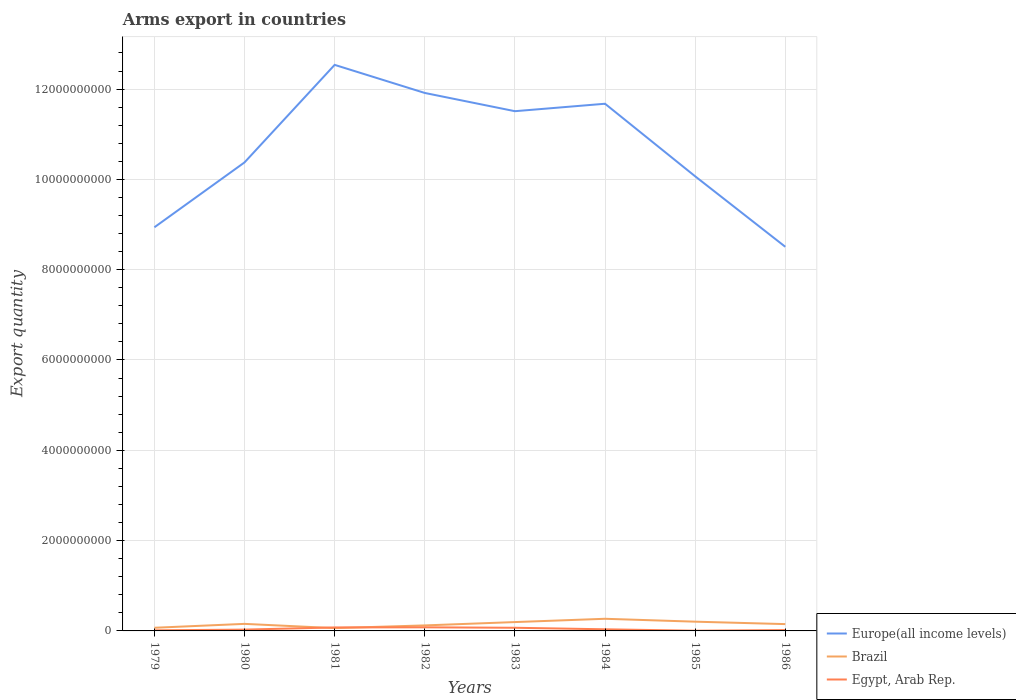Does the line corresponding to Egypt, Arab Rep. intersect with the line corresponding to Europe(all income levels)?
Ensure brevity in your answer.  No. Across all years, what is the maximum total arms export in Egypt, Arab Rep.?
Your response must be concise. 5.00e+06. In which year was the total arms export in Egypt, Arab Rep. maximum?
Your answer should be compact. 1985. What is the total total arms export in Europe(all income levels) in the graph?
Provide a short and direct response. 2.39e+08. What is the difference between the highest and the second highest total arms export in Egypt, Arab Rep.?
Your answer should be very brief. 7.50e+07. What is the difference between the highest and the lowest total arms export in Brazil?
Provide a short and direct response. 4. How many years are there in the graph?
Give a very brief answer. 8. Are the values on the major ticks of Y-axis written in scientific E-notation?
Provide a short and direct response. No. Does the graph contain grids?
Provide a short and direct response. Yes. How many legend labels are there?
Your answer should be very brief. 3. How are the legend labels stacked?
Offer a terse response. Vertical. What is the title of the graph?
Make the answer very short. Arms export in countries. Does "Jamaica" appear as one of the legend labels in the graph?
Your answer should be compact. No. What is the label or title of the X-axis?
Your answer should be very brief. Years. What is the label or title of the Y-axis?
Keep it short and to the point. Export quantity. What is the Export quantity of Europe(all income levels) in 1979?
Provide a succinct answer. 8.94e+09. What is the Export quantity of Brazil in 1979?
Give a very brief answer. 7.00e+07. What is the Export quantity in Egypt, Arab Rep. in 1979?
Your response must be concise. 1.30e+07. What is the Export quantity of Europe(all income levels) in 1980?
Ensure brevity in your answer.  1.04e+1. What is the Export quantity of Brazil in 1980?
Provide a succinct answer. 1.56e+08. What is the Export quantity in Egypt, Arab Rep. in 1980?
Provide a succinct answer. 2.90e+07. What is the Export quantity in Europe(all income levels) in 1981?
Make the answer very short. 1.25e+1. What is the Export quantity in Brazil in 1981?
Keep it short and to the point. 6.20e+07. What is the Export quantity in Egypt, Arab Rep. in 1981?
Your answer should be very brief. 7.70e+07. What is the Export quantity of Europe(all income levels) in 1982?
Provide a short and direct response. 1.19e+1. What is the Export quantity in Brazil in 1982?
Your response must be concise. 1.22e+08. What is the Export quantity in Egypt, Arab Rep. in 1982?
Give a very brief answer. 8.00e+07. What is the Export quantity of Europe(all income levels) in 1983?
Keep it short and to the point. 1.15e+1. What is the Export quantity of Brazil in 1983?
Keep it short and to the point. 1.96e+08. What is the Export quantity in Egypt, Arab Rep. in 1983?
Your response must be concise. 7.00e+07. What is the Export quantity of Europe(all income levels) in 1984?
Your answer should be compact. 1.17e+1. What is the Export quantity in Brazil in 1984?
Give a very brief answer. 2.69e+08. What is the Export quantity in Egypt, Arab Rep. in 1984?
Your response must be concise. 3.60e+07. What is the Export quantity in Europe(all income levels) in 1985?
Your response must be concise. 1.01e+1. What is the Export quantity of Brazil in 1985?
Make the answer very short. 2.05e+08. What is the Export quantity of Egypt, Arab Rep. in 1985?
Make the answer very short. 5.00e+06. What is the Export quantity of Europe(all income levels) in 1986?
Offer a very short reply. 8.51e+09. What is the Export quantity in Brazil in 1986?
Make the answer very short. 1.51e+08. What is the Export quantity in Egypt, Arab Rep. in 1986?
Provide a short and direct response. 1.90e+07. Across all years, what is the maximum Export quantity of Europe(all income levels)?
Provide a short and direct response. 1.25e+1. Across all years, what is the maximum Export quantity of Brazil?
Provide a short and direct response. 2.69e+08. Across all years, what is the maximum Export quantity in Egypt, Arab Rep.?
Your answer should be compact. 8.00e+07. Across all years, what is the minimum Export quantity of Europe(all income levels)?
Keep it short and to the point. 8.51e+09. Across all years, what is the minimum Export quantity of Brazil?
Give a very brief answer. 6.20e+07. What is the total Export quantity of Europe(all income levels) in the graph?
Provide a short and direct response. 8.55e+1. What is the total Export quantity in Brazil in the graph?
Keep it short and to the point. 1.23e+09. What is the total Export quantity in Egypt, Arab Rep. in the graph?
Provide a succinct answer. 3.29e+08. What is the difference between the Export quantity in Europe(all income levels) in 1979 and that in 1980?
Your answer should be compact. -1.44e+09. What is the difference between the Export quantity in Brazil in 1979 and that in 1980?
Keep it short and to the point. -8.60e+07. What is the difference between the Export quantity of Egypt, Arab Rep. in 1979 and that in 1980?
Your response must be concise. -1.60e+07. What is the difference between the Export quantity in Europe(all income levels) in 1979 and that in 1981?
Your answer should be very brief. -3.60e+09. What is the difference between the Export quantity in Egypt, Arab Rep. in 1979 and that in 1981?
Provide a succinct answer. -6.40e+07. What is the difference between the Export quantity in Europe(all income levels) in 1979 and that in 1982?
Your answer should be compact. -2.98e+09. What is the difference between the Export quantity of Brazil in 1979 and that in 1982?
Keep it short and to the point. -5.20e+07. What is the difference between the Export quantity in Egypt, Arab Rep. in 1979 and that in 1982?
Provide a succinct answer. -6.70e+07. What is the difference between the Export quantity of Europe(all income levels) in 1979 and that in 1983?
Provide a succinct answer. -2.57e+09. What is the difference between the Export quantity of Brazil in 1979 and that in 1983?
Your answer should be very brief. -1.26e+08. What is the difference between the Export quantity of Egypt, Arab Rep. in 1979 and that in 1983?
Your answer should be very brief. -5.70e+07. What is the difference between the Export quantity in Europe(all income levels) in 1979 and that in 1984?
Your answer should be very brief. -2.74e+09. What is the difference between the Export quantity of Brazil in 1979 and that in 1984?
Keep it short and to the point. -1.99e+08. What is the difference between the Export quantity of Egypt, Arab Rep. in 1979 and that in 1984?
Provide a succinct answer. -2.30e+07. What is the difference between the Export quantity of Europe(all income levels) in 1979 and that in 1985?
Your response must be concise. -1.13e+09. What is the difference between the Export quantity in Brazil in 1979 and that in 1985?
Keep it short and to the point. -1.35e+08. What is the difference between the Export quantity in Egypt, Arab Rep. in 1979 and that in 1985?
Your answer should be very brief. 8.00e+06. What is the difference between the Export quantity in Europe(all income levels) in 1979 and that in 1986?
Provide a succinct answer. 4.32e+08. What is the difference between the Export quantity in Brazil in 1979 and that in 1986?
Keep it short and to the point. -8.10e+07. What is the difference between the Export quantity in Egypt, Arab Rep. in 1979 and that in 1986?
Make the answer very short. -6.00e+06. What is the difference between the Export quantity of Europe(all income levels) in 1980 and that in 1981?
Provide a short and direct response. -2.16e+09. What is the difference between the Export quantity of Brazil in 1980 and that in 1981?
Your response must be concise. 9.40e+07. What is the difference between the Export quantity in Egypt, Arab Rep. in 1980 and that in 1981?
Your answer should be very brief. -4.80e+07. What is the difference between the Export quantity of Europe(all income levels) in 1980 and that in 1982?
Give a very brief answer. -1.54e+09. What is the difference between the Export quantity in Brazil in 1980 and that in 1982?
Provide a short and direct response. 3.40e+07. What is the difference between the Export quantity of Egypt, Arab Rep. in 1980 and that in 1982?
Give a very brief answer. -5.10e+07. What is the difference between the Export quantity of Europe(all income levels) in 1980 and that in 1983?
Your response must be concise. -1.13e+09. What is the difference between the Export quantity of Brazil in 1980 and that in 1983?
Offer a very short reply. -4.00e+07. What is the difference between the Export quantity in Egypt, Arab Rep. in 1980 and that in 1983?
Your answer should be very brief. -4.10e+07. What is the difference between the Export quantity in Europe(all income levels) in 1980 and that in 1984?
Keep it short and to the point. -1.30e+09. What is the difference between the Export quantity in Brazil in 1980 and that in 1984?
Your answer should be very brief. -1.13e+08. What is the difference between the Export quantity in Egypt, Arab Rep. in 1980 and that in 1984?
Offer a very short reply. -7.00e+06. What is the difference between the Export quantity in Europe(all income levels) in 1980 and that in 1985?
Make the answer very short. 3.08e+08. What is the difference between the Export quantity in Brazil in 1980 and that in 1985?
Keep it short and to the point. -4.90e+07. What is the difference between the Export quantity in Egypt, Arab Rep. in 1980 and that in 1985?
Your answer should be compact. 2.40e+07. What is the difference between the Export quantity in Europe(all income levels) in 1980 and that in 1986?
Your answer should be very brief. 1.87e+09. What is the difference between the Export quantity in Brazil in 1980 and that in 1986?
Your response must be concise. 5.00e+06. What is the difference between the Export quantity in Europe(all income levels) in 1981 and that in 1982?
Provide a succinct answer. 6.22e+08. What is the difference between the Export quantity of Brazil in 1981 and that in 1982?
Your answer should be compact. -6.00e+07. What is the difference between the Export quantity in Egypt, Arab Rep. in 1981 and that in 1982?
Make the answer very short. -3.00e+06. What is the difference between the Export quantity of Europe(all income levels) in 1981 and that in 1983?
Ensure brevity in your answer.  1.03e+09. What is the difference between the Export quantity in Brazil in 1981 and that in 1983?
Provide a succinct answer. -1.34e+08. What is the difference between the Export quantity in Europe(all income levels) in 1981 and that in 1984?
Offer a very short reply. 8.61e+08. What is the difference between the Export quantity of Brazil in 1981 and that in 1984?
Provide a short and direct response. -2.07e+08. What is the difference between the Export quantity of Egypt, Arab Rep. in 1981 and that in 1984?
Your response must be concise. 4.10e+07. What is the difference between the Export quantity of Europe(all income levels) in 1981 and that in 1985?
Your answer should be very brief. 2.47e+09. What is the difference between the Export quantity of Brazil in 1981 and that in 1985?
Ensure brevity in your answer.  -1.43e+08. What is the difference between the Export quantity of Egypt, Arab Rep. in 1981 and that in 1985?
Provide a succinct answer. 7.20e+07. What is the difference between the Export quantity in Europe(all income levels) in 1981 and that in 1986?
Provide a succinct answer. 4.03e+09. What is the difference between the Export quantity in Brazil in 1981 and that in 1986?
Your answer should be very brief. -8.90e+07. What is the difference between the Export quantity in Egypt, Arab Rep. in 1981 and that in 1986?
Ensure brevity in your answer.  5.80e+07. What is the difference between the Export quantity in Europe(all income levels) in 1982 and that in 1983?
Make the answer very short. 4.04e+08. What is the difference between the Export quantity of Brazil in 1982 and that in 1983?
Ensure brevity in your answer.  -7.40e+07. What is the difference between the Export quantity in Europe(all income levels) in 1982 and that in 1984?
Provide a short and direct response. 2.39e+08. What is the difference between the Export quantity of Brazil in 1982 and that in 1984?
Ensure brevity in your answer.  -1.47e+08. What is the difference between the Export quantity in Egypt, Arab Rep. in 1982 and that in 1984?
Keep it short and to the point. 4.40e+07. What is the difference between the Export quantity in Europe(all income levels) in 1982 and that in 1985?
Ensure brevity in your answer.  1.85e+09. What is the difference between the Export quantity of Brazil in 1982 and that in 1985?
Offer a terse response. -8.30e+07. What is the difference between the Export quantity in Egypt, Arab Rep. in 1982 and that in 1985?
Make the answer very short. 7.50e+07. What is the difference between the Export quantity in Europe(all income levels) in 1982 and that in 1986?
Your response must be concise. 3.41e+09. What is the difference between the Export quantity of Brazil in 1982 and that in 1986?
Provide a succinct answer. -2.90e+07. What is the difference between the Export quantity of Egypt, Arab Rep. in 1982 and that in 1986?
Give a very brief answer. 6.10e+07. What is the difference between the Export quantity in Europe(all income levels) in 1983 and that in 1984?
Your answer should be very brief. -1.65e+08. What is the difference between the Export quantity of Brazil in 1983 and that in 1984?
Your answer should be very brief. -7.30e+07. What is the difference between the Export quantity in Egypt, Arab Rep. in 1983 and that in 1984?
Provide a short and direct response. 3.40e+07. What is the difference between the Export quantity in Europe(all income levels) in 1983 and that in 1985?
Give a very brief answer. 1.44e+09. What is the difference between the Export quantity of Brazil in 1983 and that in 1985?
Offer a terse response. -9.00e+06. What is the difference between the Export quantity in Egypt, Arab Rep. in 1983 and that in 1985?
Offer a terse response. 6.50e+07. What is the difference between the Export quantity in Europe(all income levels) in 1983 and that in 1986?
Offer a terse response. 3.00e+09. What is the difference between the Export quantity in Brazil in 1983 and that in 1986?
Offer a terse response. 4.50e+07. What is the difference between the Export quantity in Egypt, Arab Rep. in 1983 and that in 1986?
Your answer should be compact. 5.10e+07. What is the difference between the Export quantity in Europe(all income levels) in 1984 and that in 1985?
Your answer should be compact. 1.61e+09. What is the difference between the Export quantity in Brazil in 1984 and that in 1985?
Ensure brevity in your answer.  6.40e+07. What is the difference between the Export quantity of Egypt, Arab Rep. in 1984 and that in 1985?
Offer a terse response. 3.10e+07. What is the difference between the Export quantity of Europe(all income levels) in 1984 and that in 1986?
Keep it short and to the point. 3.17e+09. What is the difference between the Export quantity of Brazil in 1984 and that in 1986?
Provide a short and direct response. 1.18e+08. What is the difference between the Export quantity in Egypt, Arab Rep. in 1984 and that in 1986?
Your response must be concise. 1.70e+07. What is the difference between the Export quantity in Europe(all income levels) in 1985 and that in 1986?
Give a very brief answer. 1.56e+09. What is the difference between the Export quantity of Brazil in 1985 and that in 1986?
Give a very brief answer. 5.40e+07. What is the difference between the Export quantity in Egypt, Arab Rep. in 1985 and that in 1986?
Offer a very short reply. -1.40e+07. What is the difference between the Export quantity in Europe(all income levels) in 1979 and the Export quantity in Brazil in 1980?
Your response must be concise. 8.78e+09. What is the difference between the Export quantity in Europe(all income levels) in 1979 and the Export quantity in Egypt, Arab Rep. in 1980?
Give a very brief answer. 8.91e+09. What is the difference between the Export quantity in Brazil in 1979 and the Export quantity in Egypt, Arab Rep. in 1980?
Provide a succinct answer. 4.10e+07. What is the difference between the Export quantity of Europe(all income levels) in 1979 and the Export quantity of Brazil in 1981?
Make the answer very short. 8.88e+09. What is the difference between the Export quantity in Europe(all income levels) in 1979 and the Export quantity in Egypt, Arab Rep. in 1981?
Your answer should be very brief. 8.86e+09. What is the difference between the Export quantity in Brazil in 1979 and the Export quantity in Egypt, Arab Rep. in 1981?
Your response must be concise. -7.00e+06. What is the difference between the Export quantity of Europe(all income levels) in 1979 and the Export quantity of Brazil in 1982?
Offer a very short reply. 8.82e+09. What is the difference between the Export quantity of Europe(all income levels) in 1979 and the Export quantity of Egypt, Arab Rep. in 1982?
Make the answer very short. 8.86e+09. What is the difference between the Export quantity in Brazil in 1979 and the Export quantity in Egypt, Arab Rep. in 1982?
Your answer should be compact. -1.00e+07. What is the difference between the Export quantity in Europe(all income levels) in 1979 and the Export quantity in Brazil in 1983?
Your answer should be very brief. 8.74e+09. What is the difference between the Export quantity of Europe(all income levels) in 1979 and the Export quantity of Egypt, Arab Rep. in 1983?
Offer a very short reply. 8.87e+09. What is the difference between the Export quantity of Brazil in 1979 and the Export quantity of Egypt, Arab Rep. in 1983?
Ensure brevity in your answer.  0. What is the difference between the Export quantity in Europe(all income levels) in 1979 and the Export quantity in Brazil in 1984?
Provide a short and direct response. 8.67e+09. What is the difference between the Export quantity of Europe(all income levels) in 1979 and the Export quantity of Egypt, Arab Rep. in 1984?
Provide a succinct answer. 8.90e+09. What is the difference between the Export quantity in Brazil in 1979 and the Export quantity in Egypt, Arab Rep. in 1984?
Your answer should be very brief. 3.40e+07. What is the difference between the Export quantity in Europe(all income levels) in 1979 and the Export quantity in Brazil in 1985?
Provide a succinct answer. 8.73e+09. What is the difference between the Export quantity of Europe(all income levels) in 1979 and the Export quantity of Egypt, Arab Rep. in 1985?
Ensure brevity in your answer.  8.93e+09. What is the difference between the Export quantity in Brazil in 1979 and the Export quantity in Egypt, Arab Rep. in 1985?
Offer a terse response. 6.50e+07. What is the difference between the Export quantity of Europe(all income levels) in 1979 and the Export quantity of Brazil in 1986?
Your answer should be very brief. 8.79e+09. What is the difference between the Export quantity of Europe(all income levels) in 1979 and the Export quantity of Egypt, Arab Rep. in 1986?
Make the answer very short. 8.92e+09. What is the difference between the Export quantity of Brazil in 1979 and the Export quantity of Egypt, Arab Rep. in 1986?
Ensure brevity in your answer.  5.10e+07. What is the difference between the Export quantity in Europe(all income levels) in 1980 and the Export quantity in Brazil in 1981?
Keep it short and to the point. 1.03e+1. What is the difference between the Export quantity in Europe(all income levels) in 1980 and the Export quantity in Egypt, Arab Rep. in 1981?
Your answer should be compact. 1.03e+1. What is the difference between the Export quantity in Brazil in 1980 and the Export quantity in Egypt, Arab Rep. in 1981?
Provide a succinct answer. 7.90e+07. What is the difference between the Export quantity in Europe(all income levels) in 1980 and the Export quantity in Brazil in 1982?
Provide a succinct answer. 1.03e+1. What is the difference between the Export quantity of Europe(all income levels) in 1980 and the Export quantity of Egypt, Arab Rep. in 1982?
Provide a short and direct response. 1.03e+1. What is the difference between the Export quantity in Brazil in 1980 and the Export quantity in Egypt, Arab Rep. in 1982?
Give a very brief answer. 7.60e+07. What is the difference between the Export quantity in Europe(all income levels) in 1980 and the Export quantity in Brazil in 1983?
Provide a succinct answer. 1.02e+1. What is the difference between the Export quantity in Europe(all income levels) in 1980 and the Export quantity in Egypt, Arab Rep. in 1983?
Make the answer very short. 1.03e+1. What is the difference between the Export quantity of Brazil in 1980 and the Export quantity of Egypt, Arab Rep. in 1983?
Give a very brief answer. 8.60e+07. What is the difference between the Export quantity in Europe(all income levels) in 1980 and the Export quantity in Brazil in 1984?
Keep it short and to the point. 1.01e+1. What is the difference between the Export quantity of Europe(all income levels) in 1980 and the Export quantity of Egypt, Arab Rep. in 1984?
Give a very brief answer. 1.03e+1. What is the difference between the Export quantity in Brazil in 1980 and the Export quantity in Egypt, Arab Rep. in 1984?
Ensure brevity in your answer.  1.20e+08. What is the difference between the Export quantity in Europe(all income levels) in 1980 and the Export quantity in Brazil in 1985?
Your response must be concise. 1.02e+1. What is the difference between the Export quantity of Europe(all income levels) in 1980 and the Export quantity of Egypt, Arab Rep. in 1985?
Your response must be concise. 1.04e+1. What is the difference between the Export quantity of Brazil in 1980 and the Export quantity of Egypt, Arab Rep. in 1985?
Your answer should be compact. 1.51e+08. What is the difference between the Export quantity in Europe(all income levels) in 1980 and the Export quantity in Brazil in 1986?
Your answer should be very brief. 1.02e+1. What is the difference between the Export quantity of Europe(all income levels) in 1980 and the Export quantity of Egypt, Arab Rep. in 1986?
Ensure brevity in your answer.  1.04e+1. What is the difference between the Export quantity of Brazil in 1980 and the Export quantity of Egypt, Arab Rep. in 1986?
Your response must be concise. 1.37e+08. What is the difference between the Export quantity in Europe(all income levels) in 1981 and the Export quantity in Brazil in 1982?
Offer a terse response. 1.24e+1. What is the difference between the Export quantity in Europe(all income levels) in 1981 and the Export quantity in Egypt, Arab Rep. in 1982?
Keep it short and to the point. 1.25e+1. What is the difference between the Export quantity in Brazil in 1981 and the Export quantity in Egypt, Arab Rep. in 1982?
Offer a terse response. -1.80e+07. What is the difference between the Export quantity in Europe(all income levels) in 1981 and the Export quantity in Brazil in 1983?
Make the answer very short. 1.23e+1. What is the difference between the Export quantity in Europe(all income levels) in 1981 and the Export quantity in Egypt, Arab Rep. in 1983?
Ensure brevity in your answer.  1.25e+1. What is the difference between the Export quantity of Brazil in 1981 and the Export quantity of Egypt, Arab Rep. in 1983?
Ensure brevity in your answer.  -8.00e+06. What is the difference between the Export quantity in Europe(all income levels) in 1981 and the Export quantity in Brazil in 1984?
Provide a succinct answer. 1.23e+1. What is the difference between the Export quantity in Europe(all income levels) in 1981 and the Export quantity in Egypt, Arab Rep. in 1984?
Provide a succinct answer. 1.25e+1. What is the difference between the Export quantity of Brazil in 1981 and the Export quantity of Egypt, Arab Rep. in 1984?
Your answer should be very brief. 2.60e+07. What is the difference between the Export quantity in Europe(all income levels) in 1981 and the Export quantity in Brazil in 1985?
Give a very brief answer. 1.23e+1. What is the difference between the Export quantity of Europe(all income levels) in 1981 and the Export quantity of Egypt, Arab Rep. in 1985?
Provide a short and direct response. 1.25e+1. What is the difference between the Export quantity in Brazil in 1981 and the Export quantity in Egypt, Arab Rep. in 1985?
Ensure brevity in your answer.  5.70e+07. What is the difference between the Export quantity in Europe(all income levels) in 1981 and the Export quantity in Brazil in 1986?
Provide a succinct answer. 1.24e+1. What is the difference between the Export quantity of Europe(all income levels) in 1981 and the Export quantity of Egypt, Arab Rep. in 1986?
Keep it short and to the point. 1.25e+1. What is the difference between the Export quantity of Brazil in 1981 and the Export quantity of Egypt, Arab Rep. in 1986?
Give a very brief answer. 4.30e+07. What is the difference between the Export quantity in Europe(all income levels) in 1982 and the Export quantity in Brazil in 1983?
Offer a very short reply. 1.17e+1. What is the difference between the Export quantity of Europe(all income levels) in 1982 and the Export quantity of Egypt, Arab Rep. in 1983?
Your answer should be compact. 1.18e+1. What is the difference between the Export quantity in Brazil in 1982 and the Export quantity in Egypt, Arab Rep. in 1983?
Keep it short and to the point. 5.20e+07. What is the difference between the Export quantity of Europe(all income levels) in 1982 and the Export quantity of Brazil in 1984?
Your answer should be compact. 1.16e+1. What is the difference between the Export quantity of Europe(all income levels) in 1982 and the Export quantity of Egypt, Arab Rep. in 1984?
Give a very brief answer. 1.19e+1. What is the difference between the Export quantity of Brazil in 1982 and the Export quantity of Egypt, Arab Rep. in 1984?
Offer a very short reply. 8.60e+07. What is the difference between the Export quantity in Europe(all income levels) in 1982 and the Export quantity in Brazil in 1985?
Give a very brief answer. 1.17e+1. What is the difference between the Export quantity in Europe(all income levels) in 1982 and the Export quantity in Egypt, Arab Rep. in 1985?
Offer a terse response. 1.19e+1. What is the difference between the Export quantity in Brazil in 1982 and the Export quantity in Egypt, Arab Rep. in 1985?
Your response must be concise. 1.17e+08. What is the difference between the Export quantity in Europe(all income levels) in 1982 and the Export quantity in Brazil in 1986?
Your answer should be compact. 1.18e+1. What is the difference between the Export quantity of Europe(all income levels) in 1982 and the Export quantity of Egypt, Arab Rep. in 1986?
Make the answer very short. 1.19e+1. What is the difference between the Export quantity in Brazil in 1982 and the Export quantity in Egypt, Arab Rep. in 1986?
Provide a short and direct response. 1.03e+08. What is the difference between the Export quantity of Europe(all income levels) in 1983 and the Export quantity of Brazil in 1984?
Your answer should be compact. 1.12e+1. What is the difference between the Export quantity in Europe(all income levels) in 1983 and the Export quantity in Egypt, Arab Rep. in 1984?
Offer a terse response. 1.15e+1. What is the difference between the Export quantity of Brazil in 1983 and the Export quantity of Egypt, Arab Rep. in 1984?
Your response must be concise. 1.60e+08. What is the difference between the Export quantity in Europe(all income levels) in 1983 and the Export quantity in Brazil in 1985?
Provide a succinct answer. 1.13e+1. What is the difference between the Export quantity in Europe(all income levels) in 1983 and the Export quantity in Egypt, Arab Rep. in 1985?
Ensure brevity in your answer.  1.15e+1. What is the difference between the Export quantity of Brazil in 1983 and the Export quantity of Egypt, Arab Rep. in 1985?
Your response must be concise. 1.91e+08. What is the difference between the Export quantity of Europe(all income levels) in 1983 and the Export quantity of Brazil in 1986?
Your answer should be compact. 1.14e+1. What is the difference between the Export quantity in Europe(all income levels) in 1983 and the Export quantity in Egypt, Arab Rep. in 1986?
Keep it short and to the point. 1.15e+1. What is the difference between the Export quantity of Brazil in 1983 and the Export quantity of Egypt, Arab Rep. in 1986?
Provide a succinct answer. 1.77e+08. What is the difference between the Export quantity of Europe(all income levels) in 1984 and the Export quantity of Brazil in 1985?
Provide a succinct answer. 1.15e+1. What is the difference between the Export quantity of Europe(all income levels) in 1984 and the Export quantity of Egypt, Arab Rep. in 1985?
Your answer should be very brief. 1.17e+1. What is the difference between the Export quantity of Brazil in 1984 and the Export quantity of Egypt, Arab Rep. in 1985?
Provide a succinct answer. 2.64e+08. What is the difference between the Export quantity of Europe(all income levels) in 1984 and the Export quantity of Brazil in 1986?
Ensure brevity in your answer.  1.15e+1. What is the difference between the Export quantity of Europe(all income levels) in 1984 and the Export quantity of Egypt, Arab Rep. in 1986?
Keep it short and to the point. 1.17e+1. What is the difference between the Export quantity of Brazil in 1984 and the Export quantity of Egypt, Arab Rep. in 1986?
Offer a very short reply. 2.50e+08. What is the difference between the Export quantity of Europe(all income levels) in 1985 and the Export quantity of Brazil in 1986?
Your response must be concise. 9.92e+09. What is the difference between the Export quantity in Europe(all income levels) in 1985 and the Export quantity in Egypt, Arab Rep. in 1986?
Your answer should be compact. 1.00e+1. What is the difference between the Export quantity of Brazil in 1985 and the Export quantity of Egypt, Arab Rep. in 1986?
Provide a succinct answer. 1.86e+08. What is the average Export quantity of Europe(all income levels) per year?
Make the answer very short. 1.07e+1. What is the average Export quantity of Brazil per year?
Ensure brevity in your answer.  1.54e+08. What is the average Export quantity of Egypt, Arab Rep. per year?
Your answer should be very brief. 4.11e+07. In the year 1979, what is the difference between the Export quantity in Europe(all income levels) and Export quantity in Brazil?
Offer a terse response. 8.87e+09. In the year 1979, what is the difference between the Export quantity of Europe(all income levels) and Export quantity of Egypt, Arab Rep.?
Keep it short and to the point. 8.93e+09. In the year 1979, what is the difference between the Export quantity of Brazil and Export quantity of Egypt, Arab Rep.?
Keep it short and to the point. 5.70e+07. In the year 1980, what is the difference between the Export quantity of Europe(all income levels) and Export quantity of Brazil?
Offer a very short reply. 1.02e+1. In the year 1980, what is the difference between the Export quantity in Europe(all income levels) and Export quantity in Egypt, Arab Rep.?
Your response must be concise. 1.03e+1. In the year 1980, what is the difference between the Export quantity in Brazil and Export quantity in Egypt, Arab Rep.?
Keep it short and to the point. 1.27e+08. In the year 1981, what is the difference between the Export quantity of Europe(all income levels) and Export quantity of Brazil?
Your answer should be very brief. 1.25e+1. In the year 1981, what is the difference between the Export quantity in Europe(all income levels) and Export quantity in Egypt, Arab Rep.?
Ensure brevity in your answer.  1.25e+1. In the year 1981, what is the difference between the Export quantity in Brazil and Export quantity in Egypt, Arab Rep.?
Offer a terse response. -1.50e+07. In the year 1982, what is the difference between the Export quantity of Europe(all income levels) and Export quantity of Brazil?
Offer a terse response. 1.18e+1. In the year 1982, what is the difference between the Export quantity in Europe(all income levels) and Export quantity in Egypt, Arab Rep.?
Ensure brevity in your answer.  1.18e+1. In the year 1982, what is the difference between the Export quantity of Brazil and Export quantity of Egypt, Arab Rep.?
Your answer should be compact. 4.20e+07. In the year 1983, what is the difference between the Export quantity of Europe(all income levels) and Export quantity of Brazil?
Your response must be concise. 1.13e+1. In the year 1983, what is the difference between the Export quantity of Europe(all income levels) and Export quantity of Egypt, Arab Rep.?
Offer a very short reply. 1.14e+1. In the year 1983, what is the difference between the Export quantity of Brazil and Export quantity of Egypt, Arab Rep.?
Provide a short and direct response. 1.26e+08. In the year 1984, what is the difference between the Export quantity of Europe(all income levels) and Export quantity of Brazil?
Ensure brevity in your answer.  1.14e+1. In the year 1984, what is the difference between the Export quantity of Europe(all income levels) and Export quantity of Egypt, Arab Rep.?
Keep it short and to the point. 1.16e+1. In the year 1984, what is the difference between the Export quantity of Brazil and Export quantity of Egypt, Arab Rep.?
Offer a terse response. 2.33e+08. In the year 1985, what is the difference between the Export quantity in Europe(all income levels) and Export quantity in Brazil?
Provide a succinct answer. 9.86e+09. In the year 1985, what is the difference between the Export quantity of Europe(all income levels) and Export quantity of Egypt, Arab Rep.?
Keep it short and to the point. 1.01e+1. In the year 1986, what is the difference between the Export quantity of Europe(all income levels) and Export quantity of Brazil?
Your answer should be compact. 8.36e+09. In the year 1986, what is the difference between the Export quantity in Europe(all income levels) and Export quantity in Egypt, Arab Rep.?
Make the answer very short. 8.49e+09. In the year 1986, what is the difference between the Export quantity in Brazil and Export quantity in Egypt, Arab Rep.?
Ensure brevity in your answer.  1.32e+08. What is the ratio of the Export quantity in Europe(all income levels) in 1979 to that in 1980?
Make the answer very short. 0.86. What is the ratio of the Export quantity of Brazil in 1979 to that in 1980?
Offer a terse response. 0.45. What is the ratio of the Export quantity in Egypt, Arab Rep. in 1979 to that in 1980?
Offer a terse response. 0.45. What is the ratio of the Export quantity of Europe(all income levels) in 1979 to that in 1981?
Offer a terse response. 0.71. What is the ratio of the Export quantity in Brazil in 1979 to that in 1981?
Make the answer very short. 1.13. What is the ratio of the Export quantity of Egypt, Arab Rep. in 1979 to that in 1981?
Your answer should be compact. 0.17. What is the ratio of the Export quantity in Europe(all income levels) in 1979 to that in 1982?
Provide a short and direct response. 0.75. What is the ratio of the Export quantity of Brazil in 1979 to that in 1982?
Offer a terse response. 0.57. What is the ratio of the Export quantity of Egypt, Arab Rep. in 1979 to that in 1982?
Give a very brief answer. 0.16. What is the ratio of the Export quantity of Europe(all income levels) in 1979 to that in 1983?
Ensure brevity in your answer.  0.78. What is the ratio of the Export quantity in Brazil in 1979 to that in 1983?
Provide a succinct answer. 0.36. What is the ratio of the Export quantity in Egypt, Arab Rep. in 1979 to that in 1983?
Your answer should be very brief. 0.19. What is the ratio of the Export quantity of Europe(all income levels) in 1979 to that in 1984?
Keep it short and to the point. 0.77. What is the ratio of the Export quantity in Brazil in 1979 to that in 1984?
Your response must be concise. 0.26. What is the ratio of the Export quantity of Egypt, Arab Rep. in 1979 to that in 1984?
Provide a succinct answer. 0.36. What is the ratio of the Export quantity of Europe(all income levels) in 1979 to that in 1985?
Give a very brief answer. 0.89. What is the ratio of the Export quantity of Brazil in 1979 to that in 1985?
Keep it short and to the point. 0.34. What is the ratio of the Export quantity of Europe(all income levels) in 1979 to that in 1986?
Provide a short and direct response. 1.05. What is the ratio of the Export quantity in Brazil in 1979 to that in 1986?
Offer a terse response. 0.46. What is the ratio of the Export quantity of Egypt, Arab Rep. in 1979 to that in 1986?
Offer a very short reply. 0.68. What is the ratio of the Export quantity of Europe(all income levels) in 1980 to that in 1981?
Provide a succinct answer. 0.83. What is the ratio of the Export quantity in Brazil in 1980 to that in 1981?
Keep it short and to the point. 2.52. What is the ratio of the Export quantity of Egypt, Arab Rep. in 1980 to that in 1981?
Keep it short and to the point. 0.38. What is the ratio of the Export quantity in Europe(all income levels) in 1980 to that in 1982?
Give a very brief answer. 0.87. What is the ratio of the Export quantity in Brazil in 1980 to that in 1982?
Provide a short and direct response. 1.28. What is the ratio of the Export quantity of Egypt, Arab Rep. in 1980 to that in 1982?
Keep it short and to the point. 0.36. What is the ratio of the Export quantity in Europe(all income levels) in 1980 to that in 1983?
Provide a short and direct response. 0.9. What is the ratio of the Export quantity in Brazil in 1980 to that in 1983?
Keep it short and to the point. 0.8. What is the ratio of the Export quantity in Egypt, Arab Rep. in 1980 to that in 1983?
Ensure brevity in your answer.  0.41. What is the ratio of the Export quantity in Europe(all income levels) in 1980 to that in 1984?
Your answer should be very brief. 0.89. What is the ratio of the Export quantity in Brazil in 1980 to that in 1984?
Keep it short and to the point. 0.58. What is the ratio of the Export quantity in Egypt, Arab Rep. in 1980 to that in 1984?
Keep it short and to the point. 0.81. What is the ratio of the Export quantity in Europe(all income levels) in 1980 to that in 1985?
Provide a succinct answer. 1.03. What is the ratio of the Export quantity of Brazil in 1980 to that in 1985?
Provide a short and direct response. 0.76. What is the ratio of the Export quantity of Egypt, Arab Rep. in 1980 to that in 1985?
Offer a very short reply. 5.8. What is the ratio of the Export quantity of Europe(all income levels) in 1980 to that in 1986?
Your answer should be very brief. 1.22. What is the ratio of the Export quantity of Brazil in 1980 to that in 1986?
Ensure brevity in your answer.  1.03. What is the ratio of the Export quantity of Egypt, Arab Rep. in 1980 to that in 1986?
Provide a short and direct response. 1.53. What is the ratio of the Export quantity in Europe(all income levels) in 1981 to that in 1982?
Provide a succinct answer. 1.05. What is the ratio of the Export quantity in Brazil in 1981 to that in 1982?
Offer a terse response. 0.51. What is the ratio of the Export quantity in Egypt, Arab Rep. in 1981 to that in 1982?
Keep it short and to the point. 0.96. What is the ratio of the Export quantity in Europe(all income levels) in 1981 to that in 1983?
Provide a short and direct response. 1.09. What is the ratio of the Export quantity in Brazil in 1981 to that in 1983?
Make the answer very short. 0.32. What is the ratio of the Export quantity of Egypt, Arab Rep. in 1981 to that in 1983?
Your answer should be very brief. 1.1. What is the ratio of the Export quantity of Europe(all income levels) in 1981 to that in 1984?
Provide a succinct answer. 1.07. What is the ratio of the Export quantity in Brazil in 1981 to that in 1984?
Offer a very short reply. 0.23. What is the ratio of the Export quantity in Egypt, Arab Rep. in 1981 to that in 1984?
Ensure brevity in your answer.  2.14. What is the ratio of the Export quantity of Europe(all income levels) in 1981 to that in 1985?
Make the answer very short. 1.25. What is the ratio of the Export quantity in Brazil in 1981 to that in 1985?
Your answer should be compact. 0.3. What is the ratio of the Export quantity of Egypt, Arab Rep. in 1981 to that in 1985?
Offer a terse response. 15.4. What is the ratio of the Export quantity of Europe(all income levels) in 1981 to that in 1986?
Your answer should be compact. 1.47. What is the ratio of the Export quantity of Brazil in 1981 to that in 1986?
Give a very brief answer. 0.41. What is the ratio of the Export quantity in Egypt, Arab Rep. in 1981 to that in 1986?
Offer a terse response. 4.05. What is the ratio of the Export quantity in Europe(all income levels) in 1982 to that in 1983?
Your answer should be compact. 1.04. What is the ratio of the Export quantity in Brazil in 1982 to that in 1983?
Ensure brevity in your answer.  0.62. What is the ratio of the Export quantity in Europe(all income levels) in 1982 to that in 1984?
Your answer should be compact. 1.02. What is the ratio of the Export quantity in Brazil in 1982 to that in 1984?
Ensure brevity in your answer.  0.45. What is the ratio of the Export quantity in Egypt, Arab Rep. in 1982 to that in 1984?
Provide a short and direct response. 2.22. What is the ratio of the Export quantity of Europe(all income levels) in 1982 to that in 1985?
Offer a very short reply. 1.18. What is the ratio of the Export quantity of Brazil in 1982 to that in 1985?
Provide a short and direct response. 0.6. What is the ratio of the Export quantity of Egypt, Arab Rep. in 1982 to that in 1985?
Keep it short and to the point. 16. What is the ratio of the Export quantity of Europe(all income levels) in 1982 to that in 1986?
Provide a succinct answer. 1.4. What is the ratio of the Export quantity of Brazil in 1982 to that in 1986?
Your answer should be compact. 0.81. What is the ratio of the Export quantity in Egypt, Arab Rep. in 1982 to that in 1986?
Keep it short and to the point. 4.21. What is the ratio of the Export quantity of Europe(all income levels) in 1983 to that in 1984?
Your response must be concise. 0.99. What is the ratio of the Export quantity of Brazil in 1983 to that in 1984?
Make the answer very short. 0.73. What is the ratio of the Export quantity of Egypt, Arab Rep. in 1983 to that in 1984?
Ensure brevity in your answer.  1.94. What is the ratio of the Export quantity in Europe(all income levels) in 1983 to that in 1985?
Provide a succinct answer. 1.14. What is the ratio of the Export quantity in Brazil in 1983 to that in 1985?
Your answer should be compact. 0.96. What is the ratio of the Export quantity in Egypt, Arab Rep. in 1983 to that in 1985?
Provide a succinct answer. 14. What is the ratio of the Export quantity of Europe(all income levels) in 1983 to that in 1986?
Ensure brevity in your answer.  1.35. What is the ratio of the Export quantity in Brazil in 1983 to that in 1986?
Ensure brevity in your answer.  1.3. What is the ratio of the Export quantity in Egypt, Arab Rep. in 1983 to that in 1986?
Provide a short and direct response. 3.68. What is the ratio of the Export quantity of Europe(all income levels) in 1984 to that in 1985?
Offer a terse response. 1.16. What is the ratio of the Export quantity of Brazil in 1984 to that in 1985?
Provide a succinct answer. 1.31. What is the ratio of the Export quantity of Europe(all income levels) in 1984 to that in 1986?
Your answer should be compact. 1.37. What is the ratio of the Export quantity of Brazil in 1984 to that in 1986?
Keep it short and to the point. 1.78. What is the ratio of the Export quantity in Egypt, Arab Rep. in 1984 to that in 1986?
Offer a terse response. 1.89. What is the ratio of the Export quantity of Europe(all income levels) in 1985 to that in 1986?
Keep it short and to the point. 1.18. What is the ratio of the Export quantity of Brazil in 1985 to that in 1986?
Your answer should be compact. 1.36. What is the ratio of the Export quantity in Egypt, Arab Rep. in 1985 to that in 1986?
Offer a very short reply. 0.26. What is the difference between the highest and the second highest Export quantity of Europe(all income levels)?
Your response must be concise. 6.22e+08. What is the difference between the highest and the second highest Export quantity of Brazil?
Your answer should be compact. 6.40e+07. What is the difference between the highest and the lowest Export quantity of Europe(all income levels)?
Provide a short and direct response. 4.03e+09. What is the difference between the highest and the lowest Export quantity of Brazil?
Ensure brevity in your answer.  2.07e+08. What is the difference between the highest and the lowest Export quantity in Egypt, Arab Rep.?
Your response must be concise. 7.50e+07. 